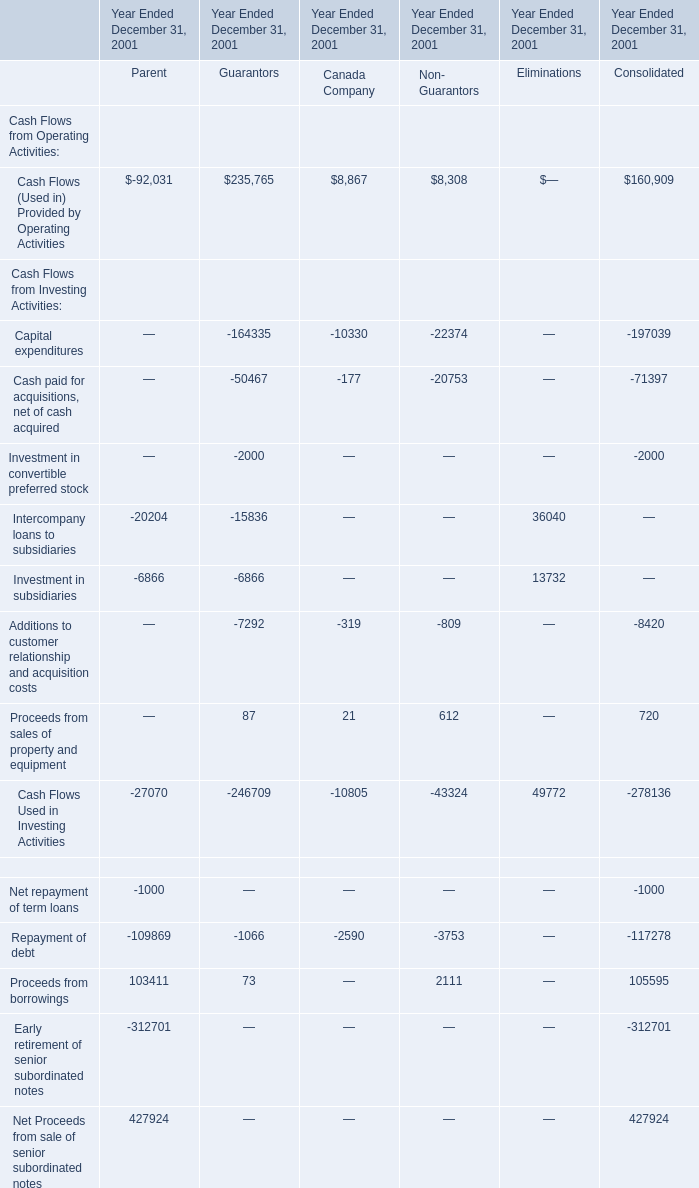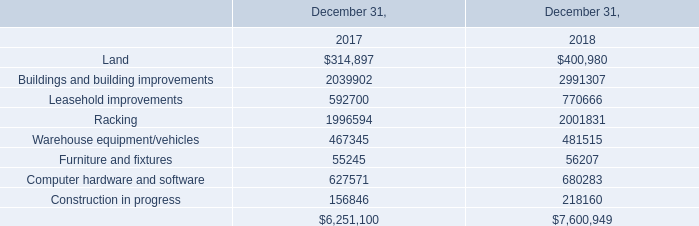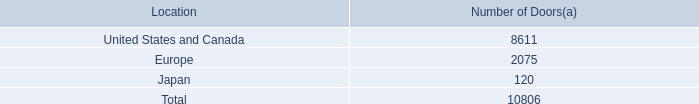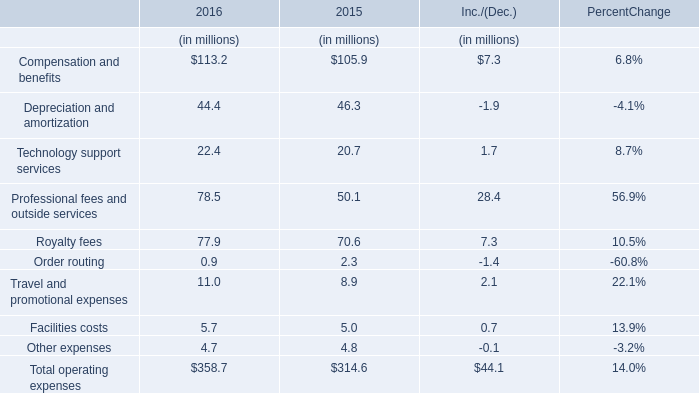In which section the sum of Cash Flows (Used in) Provided by Operating Activities has the highest value? 
Answer: Guarantors. 